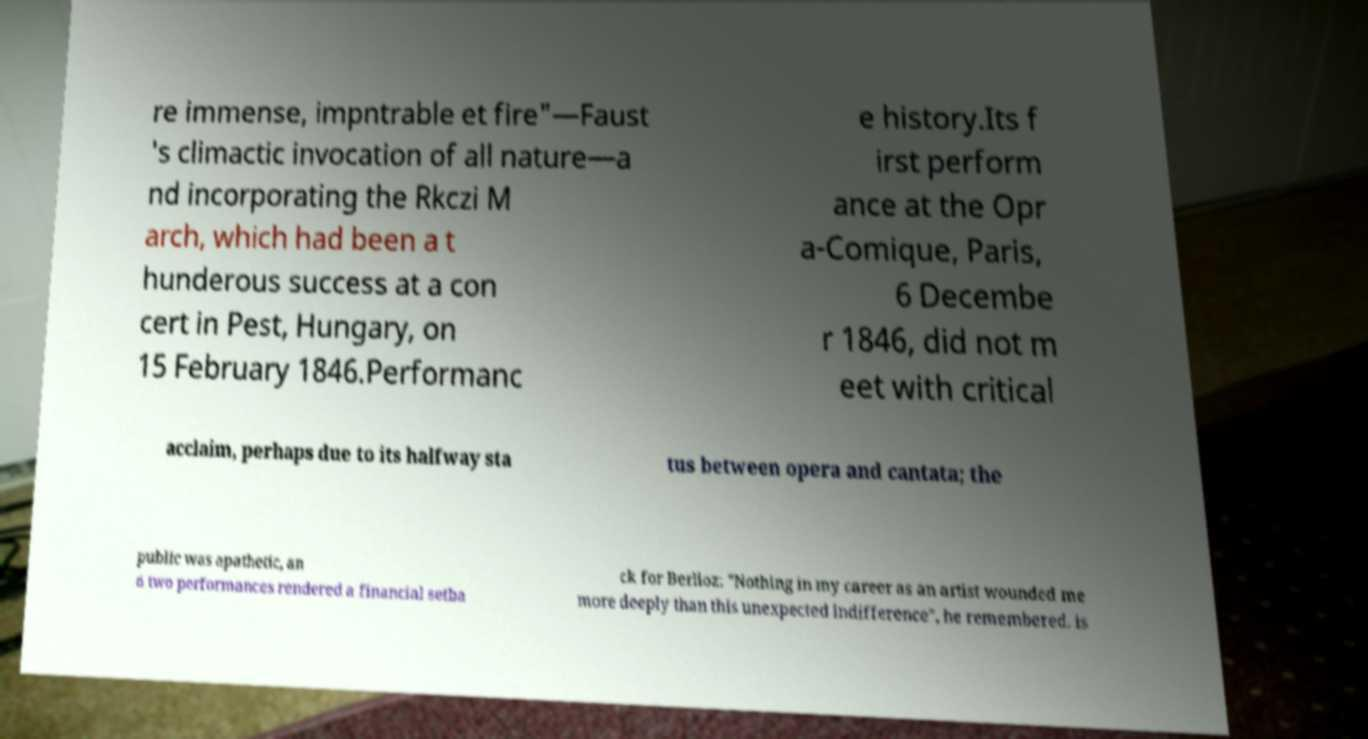Can you read and provide the text displayed in the image?This photo seems to have some interesting text. Can you extract and type it out for me? re immense, impntrable et fire"—Faust 's climactic invocation of all nature—a nd incorporating the Rkczi M arch, which had been a t hunderous success at a con cert in Pest, Hungary, on 15 February 1846.Performanc e history.Its f irst perform ance at the Opr a-Comique, Paris, 6 Decembe r 1846, did not m eet with critical acclaim, perhaps due to its halfway sta tus between opera and cantata; the public was apathetic, an d two performances rendered a financial setba ck for Berlioz: "Nothing in my career as an artist wounded me more deeply than this unexpected indifference", he remembered. is 